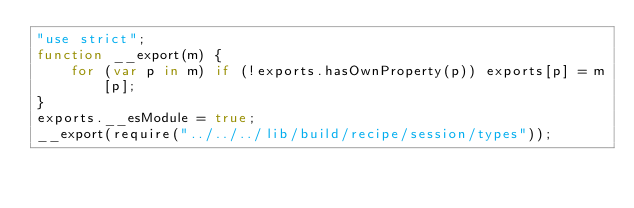Convert code to text. <code><loc_0><loc_0><loc_500><loc_500><_JavaScript_>"use strict";
function __export(m) {
    for (var p in m) if (!exports.hasOwnProperty(p)) exports[p] = m[p];
}
exports.__esModule = true;
__export(require("../../../lib/build/recipe/session/types"));
</code> 